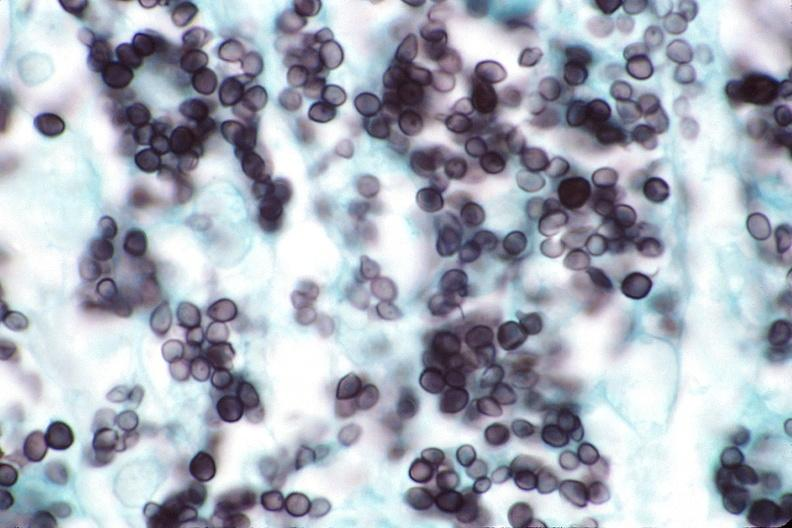s wonder present?
Answer the question using a single word or phrase. No 